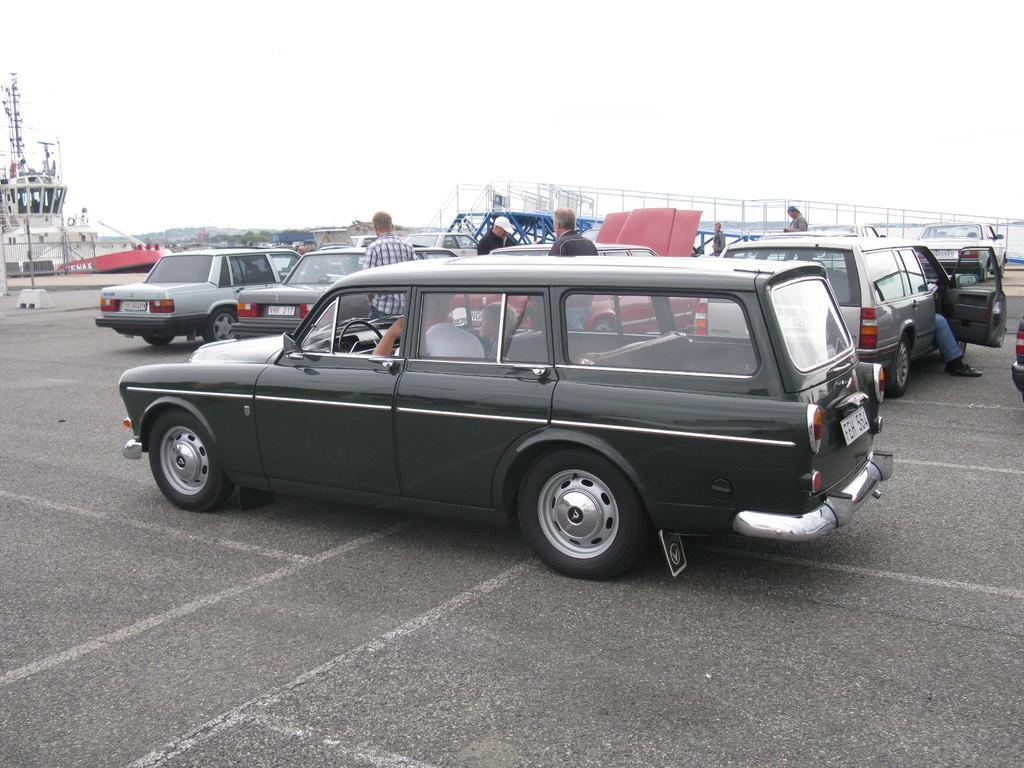Could you give a brief overview of what you see in this image? In this image I can see many vehicles on the road. These vehicles are in different color. To the side of these vehicle few people are standing and few people are sitting inside the vehicles. To the left I can see the ship. In the back I can see the white sky. 